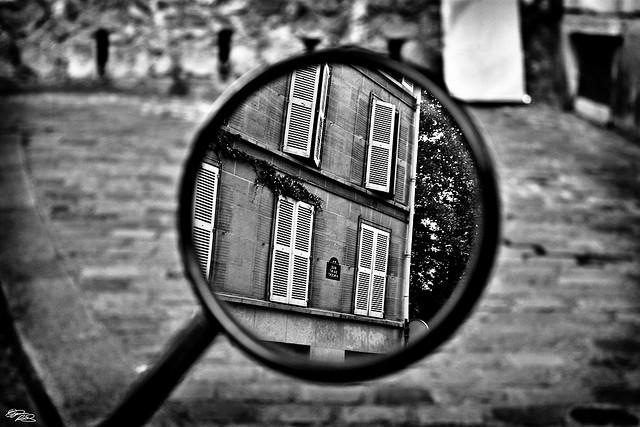Is this a mirror?
Answer briefly. Yes. Is there a sign on the building reflected?
Write a very short answer. Yes. What is growing on the house?
Answer briefly. Ivy. 